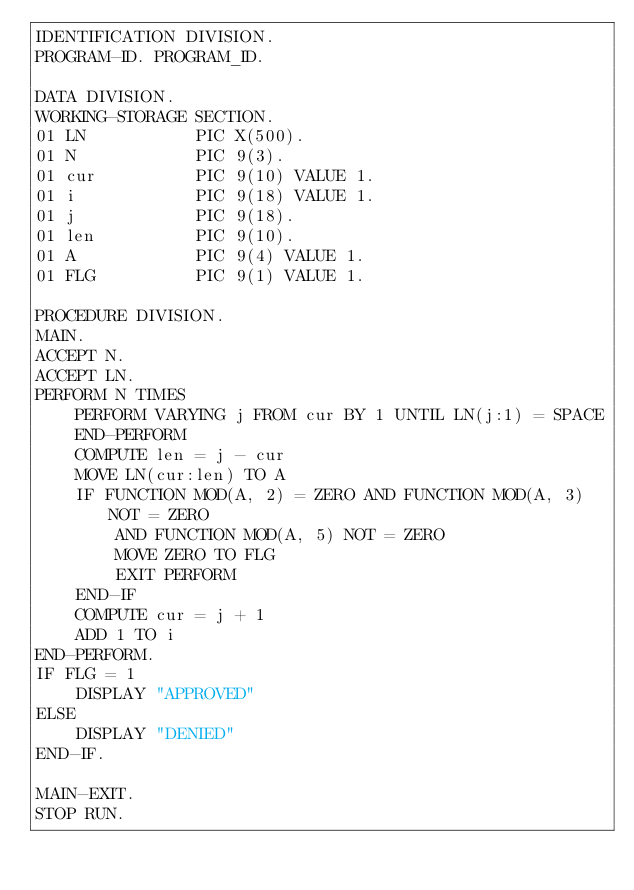Convert code to text. <code><loc_0><loc_0><loc_500><loc_500><_COBOL_>IDENTIFICATION DIVISION.
PROGRAM-ID. PROGRAM_ID.

DATA DIVISION.
WORKING-STORAGE SECTION.
01 LN           PIC X(500).
01 N            PIC 9(3).
01 cur          PIC 9(10) VALUE 1.
01 i            PIC 9(18) VALUE 1.
01 j            PIC 9(18).
01 len          PIC 9(10). 
01 A            PIC 9(4) VALUE 1.
01 FLG          PIC 9(1) VALUE 1.

PROCEDURE DIVISION.
MAIN.
ACCEPT N.
ACCEPT LN.
PERFORM N TIMES
    PERFORM VARYING j FROM cur BY 1 UNTIL LN(j:1) = SPACE
    END-PERFORM
    COMPUTE len = j - cur
    MOVE LN(cur:len) TO A
    IF FUNCTION MOD(A, 2) = ZERO AND FUNCTION MOD(A, 3) NOT = ZERO
        AND FUNCTION MOD(A, 5) NOT = ZERO
        MOVE ZERO TO FLG
        EXIT PERFORM
    END-IF
    COMPUTE cur = j + 1
    ADD 1 TO i
END-PERFORM.
IF FLG = 1
    DISPLAY "APPROVED"
ELSE
    DISPLAY "DENIED"
END-IF.

MAIN-EXIT.
STOP RUN.
</code> 